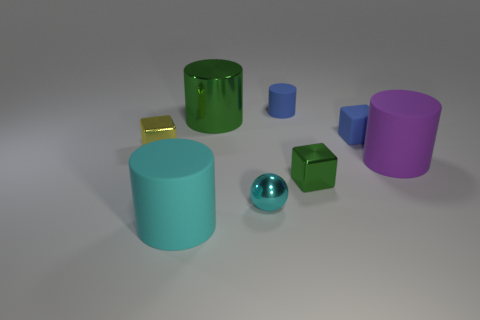Subtract all matte blocks. How many blocks are left? 2 Add 2 small purple objects. How many objects exist? 10 Subtract all blue cylinders. How many cylinders are left? 3 Add 7 big things. How many big things are left? 10 Add 3 big brown blocks. How many big brown blocks exist? 3 Subtract 0 gray cubes. How many objects are left? 8 Subtract all cubes. How many objects are left? 5 Subtract 1 spheres. How many spheres are left? 0 Subtract all brown blocks. Subtract all yellow spheres. How many blocks are left? 3 Subtract all gray cylinders. How many green cubes are left? 1 